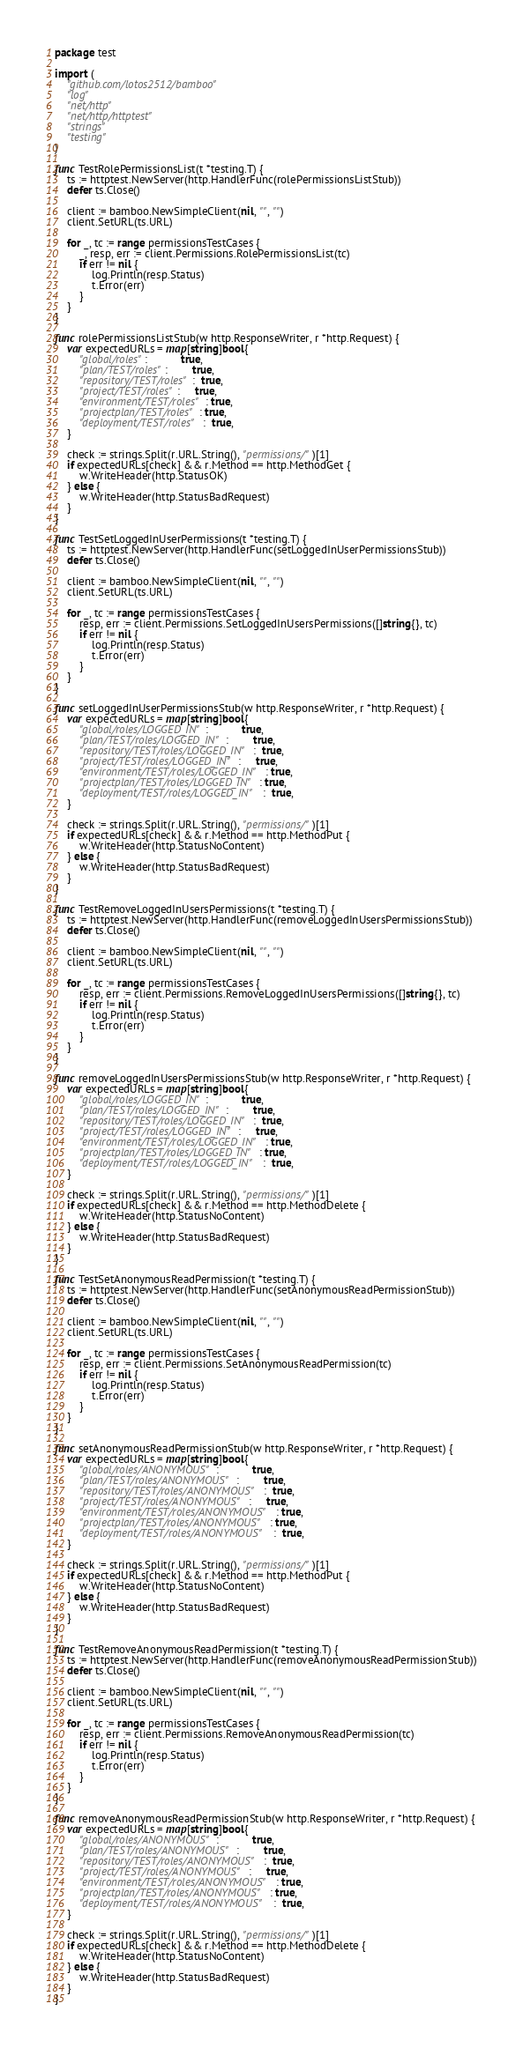Convert code to text. <code><loc_0><loc_0><loc_500><loc_500><_Go_>package test

import (
	"github.com/lotos2512/bamboo"
	"log"
	"net/http"
	"net/http/httptest"
	"strings"
	"testing"
)

func TestRolePermissionsList(t *testing.T) {
	ts := httptest.NewServer(http.HandlerFunc(rolePermissionsListStub))
	defer ts.Close()

	client := bamboo.NewSimpleClient(nil, "", "")
	client.SetURL(ts.URL)

	for _, tc := range permissionsTestCases {
		_, resp, err := client.Permissions.RolePermissionsList(tc)
		if err != nil {
			log.Println(resp.Status)
			t.Error(err)
		}
	}
}

func rolePermissionsListStub(w http.ResponseWriter, r *http.Request) {
	var expectedURLs = map[string]bool{
		"global/roles":           true,
		"plan/TEST/roles":        true,
		"repository/TEST/roles":  true,
		"project/TEST/roles":     true,
		"environment/TEST/roles": true,
		"projectplan/TEST/roles": true,
		"deployment/TEST/roles":  true,
	}

	check := strings.Split(r.URL.String(), "permissions/")[1]
	if expectedURLs[check] && r.Method == http.MethodGet {
		w.WriteHeader(http.StatusOK)
	} else {
		w.WriteHeader(http.StatusBadRequest)
	}
}

func TestSetLoggedInUserPermissions(t *testing.T) {
	ts := httptest.NewServer(http.HandlerFunc(setLoggedInUserPermissionsStub))
	defer ts.Close()

	client := bamboo.NewSimpleClient(nil, "", "")
	client.SetURL(ts.URL)

	for _, tc := range permissionsTestCases {
		resp, err := client.Permissions.SetLoggedInUsersPermissions([]string{}, tc)
		if err != nil {
			log.Println(resp.Status)
			t.Error(err)
		}
	}
}

func setLoggedInUserPermissionsStub(w http.ResponseWriter, r *http.Request) {
	var expectedURLs = map[string]bool{
		"global/roles/LOGGED_IN":           true,
		"plan/TEST/roles/LOGGED_IN":        true,
		"repository/TEST/roles/LOGGED_IN":  true,
		"project/TEST/roles/LOGGED_IN":     true,
		"environment/TEST/roles/LOGGED_IN": true,
		"projectplan/TEST/roles/LOGGED_IN": true,
		"deployment/TEST/roles/LOGGED_IN":  true,
	}

	check := strings.Split(r.URL.String(), "permissions/")[1]
	if expectedURLs[check] && r.Method == http.MethodPut {
		w.WriteHeader(http.StatusNoContent)
	} else {
		w.WriteHeader(http.StatusBadRequest)
	}
}

func TestRemoveLoggedInUsersPermissions(t *testing.T) {
	ts := httptest.NewServer(http.HandlerFunc(removeLoggedInUsersPermissionsStub))
	defer ts.Close()

	client := bamboo.NewSimpleClient(nil, "", "")
	client.SetURL(ts.URL)

	for _, tc := range permissionsTestCases {
		resp, err := client.Permissions.RemoveLoggedInUsersPermissions([]string{}, tc)
		if err != nil {
			log.Println(resp.Status)
			t.Error(err)
		}
	}
}

func removeLoggedInUsersPermissionsStub(w http.ResponseWriter, r *http.Request) {
	var expectedURLs = map[string]bool{
		"global/roles/LOGGED_IN":           true,
		"plan/TEST/roles/LOGGED_IN":        true,
		"repository/TEST/roles/LOGGED_IN":  true,
		"project/TEST/roles/LOGGED_IN":     true,
		"environment/TEST/roles/LOGGED_IN": true,
		"projectplan/TEST/roles/LOGGED_IN": true,
		"deployment/TEST/roles/LOGGED_IN":  true,
	}

	check := strings.Split(r.URL.String(), "permissions/")[1]
	if expectedURLs[check] && r.Method == http.MethodDelete {
		w.WriteHeader(http.StatusNoContent)
	} else {
		w.WriteHeader(http.StatusBadRequest)
	}
}

func TestSetAnonymousReadPermission(t *testing.T) {
	ts := httptest.NewServer(http.HandlerFunc(setAnonymousReadPermissionStub))
	defer ts.Close()

	client := bamboo.NewSimpleClient(nil, "", "")
	client.SetURL(ts.URL)

	for _, tc := range permissionsTestCases {
		resp, err := client.Permissions.SetAnonymousReadPermission(tc)
		if err != nil {
			log.Println(resp.Status)
			t.Error(err)
		}
	}
}

func setAnonymousReadPermissionStub(w http.ResponseWriter, r *http.Request) {
	var expectedURLs = map[string]bool{
		"global/roles/ANONYMOUS":           true,
		"plan/TEST/roles/ANONYMOUS":        true,
		"repository/TEST/roles/ANONYMOUS":  true,
		"project/TEST/roles/ANONYMOUS":     true,
		"environment/TEST/roles/ANONYMOUS": true,
		"projectplan/TEST/roles/ANONYMOUS": true,
		"deployment/TEST/roles/ANONYMOUS":  true,
	}

	check := strings.Split(r.URL.String(), "permissions/")[1]
	if expectedURLs[check] && r.Method == http.MethodPut {
		w.WriteHeader(http.StatusNoContent)
	} else {
		w.WriteHeader(http.StatusBadRequest)
	}
}

func TestRemoveAnonymousReadPermission(t *testing.T) {
	ts := httptest.NewServer(http.HandlerFunc(removeAnonymousReadPermissionStub))
	defer ts.Close()

	client := bamboo.NewSimpleClient(nil, "", "")
	client.SetURL(ts.URL)

	for _, tc := range permissionsTestCases {
		resp, err := client.Permissions.RemoveAnonymousReadPermission(tc)
		if err != nil {
			log.Println(resp.Status)
			t.Error(err)
		}
	}
}

func removeAnonymousReadPermissionStub(w http.ResponseWriter, r *http.Request) {
	var expectedURLs = map[string]bool{
		"global/roles/ANONYMOUS":           true,
		"plan/TEST/roles/ANONYMOUS":        true,
		"repository/TEST/roles/ANONYMOUS":  true,
		"project/TEST/roles/ANONYMOUS":     true,
		"environment/TEST/roles/ANONYMOUS": true,
		"projectplan/TEST/roles/ANONYMOUS": true,
		"deployment/TEST/roles/ANONYMOUS":  true,
	}

	check := strings.Split(r.URL.String(), "permissions/")[1]
	if expectedURLs[check] && r.Method == http.MethodDelete {
		w.WriteHeader(http.StatusNoContent)
	} else {
		w.WriteHeader(http.StatusBadRequest)
	}
}
</code> 